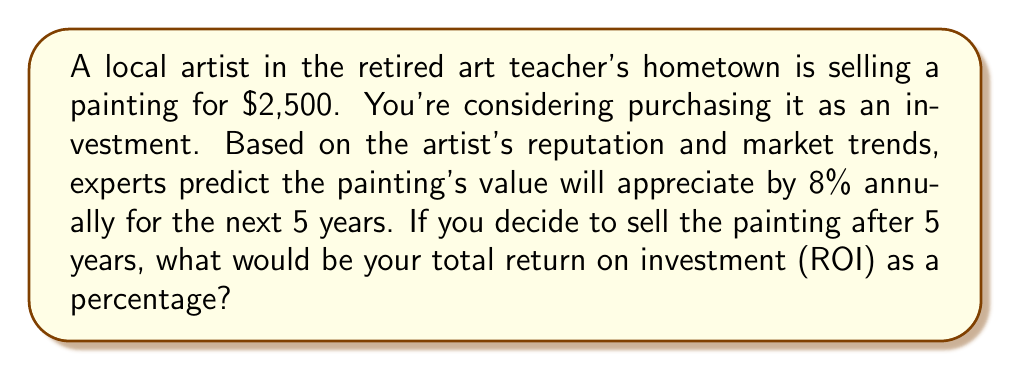Provide a solution to this math problem. To solve this problem, we'll follow these steps:

1. Calculate the future value of the painting after 5 years:
   The future value can be calculated using the compound interest formula:
   $$FV = PV \times (1 + r)^t$$
   Where:
   $FV$ = Future Value
   $PV$ = Present Value (initial investment)
   $r$ = Annual rate of return
   $t$ = Number of years

   $$FV = 2500 \times (1 + 0.08)^5 = 2500 \times 1.46933 = 3673.33$$

2. Calculate the total gain:
   Total Gain = Future Value - Initial Investment
   $$Total Gain = 3673.33 - 2500 = 1173.33$$

3. Calculate the ROI as a percentage:
   $$ROI (\%) = \frac{Total Gain}{Initial Investment} \times 100$$
   
   $$ROI (\%) = \frac{1173.33}{2500} \times 100 = 46.93\%$$

Therefore, the total return on investment after 5 years would be approximately 46.93%.
Answer: 46.93% 